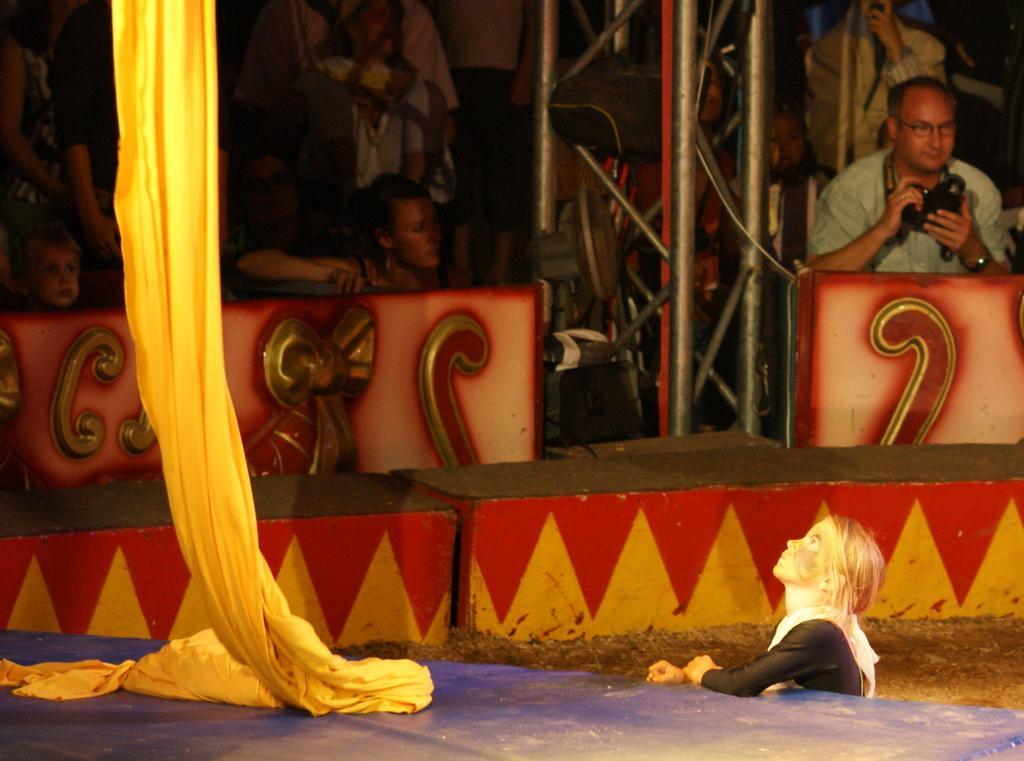In one or two sentences, can you explain what this image depicts? This image is taken outdoors. At the bottom of the image there is a dais. In the background a few people are standing and a few are sitting. A man is holding a camera in his hands and there are a few iron bars. There is a wall and there are a few carvings on the wall. In the middle of the image there is a cloth which is yellow in color and a girl is sitting on the ground. 